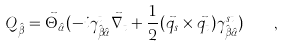Convert formula to latex. <formula><loc_0><loc_0><loc_500><loc_500>Q _ { \hat { \beta } } = \vec { \Theta } _ { \hat { \alpha } } ( - i \gamma ^ { t } _ { \hat { \beta } \hat { \alpha } } \vec { \nabla } _ { t } + \frac { 1 } { 2 } ( \vec { q } _ { s } \times \vec { q } _ { t } ) \gamma ^ { s t } _ { \hat { \beta } \hat { \alpha } } ) \quad ,</formula> 